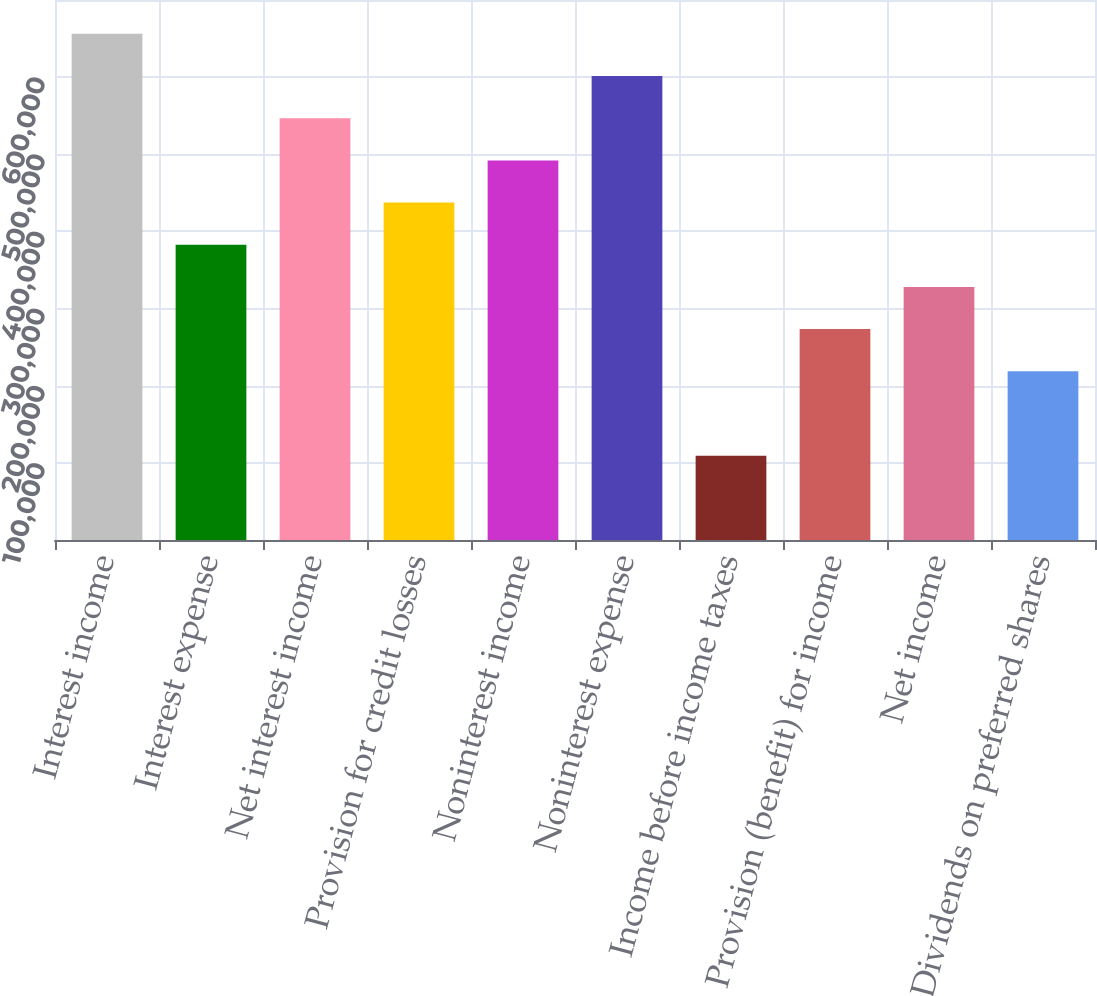<chart> <loc_0><loc_0><loc_500><loc_500><bar_chart><fcel>Interest income<fcel>Interest expense<fcel>Net interest income<fcel>Provision for credit losses<fcel>Noninterest income<fcel>Noninterest expense<fcel>Income before income taxes<fcel>Provision (benefit) for income<fcel>Net income<fcel>Dividends on preferred shares<nl><fcel>656135<fcel>382745<fcel>546779<fcel>437423<fcel>492101<fcel>601457<fcel>109356<fcel>273390<fcel>328067<fcel>218712<nl></chart> 